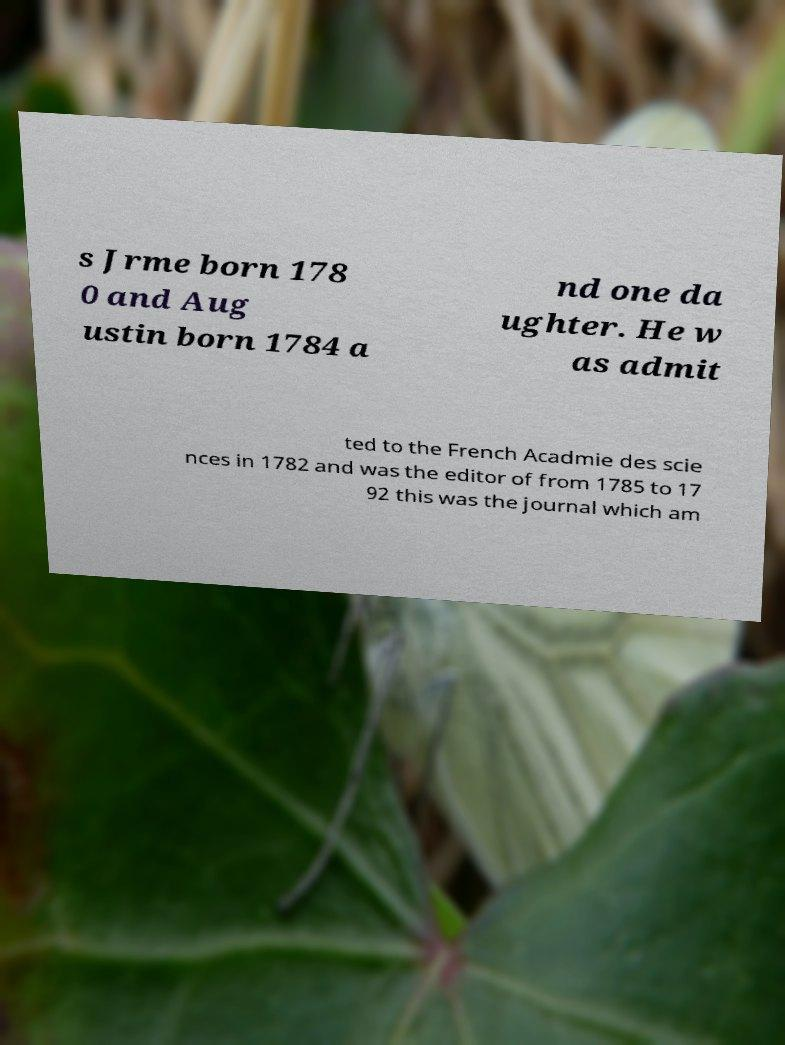There's text embedded in this image that I need extracted. Can you transcribe it verbatim? s Jrme born 178 0 and Aug ustin born 1784 a nd one da ughter. He w as admit ted to the French Acadmie des scie nces in 1782 and was the editor of from 1785 to 17 92 this was the journal which am 